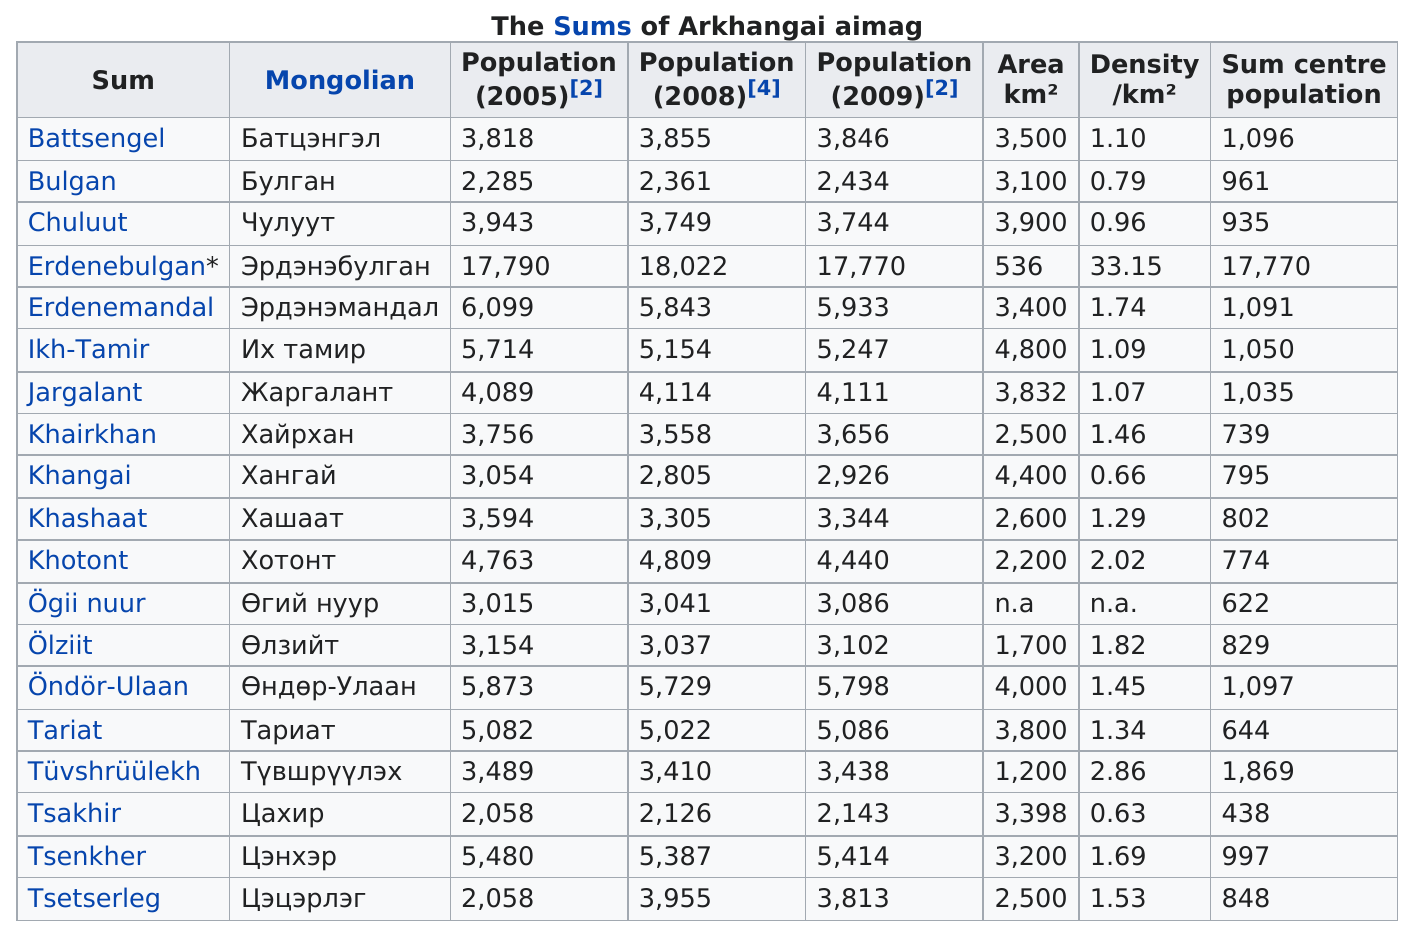Give some essential details in this illustration. The specific sum of Ögii nuur is the only one listed without an area or density provided. There are 19 different sums that can be made from the numbers 1 through 9. According to recorded data, the city of Erdenebulgan has the least amount of area out of any city mentioned, with 'n.a.' recorded for any other city. In 2005, the city with the largest population recorded was Erdenebulgan. The city with the greatest population change from 2005 to 2009 was Tsetserleg. 